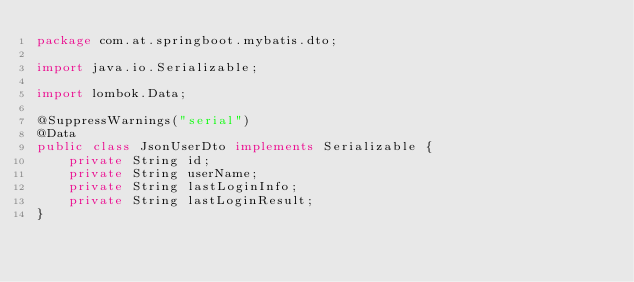Convert code to text. <code><loc_0><loc_0><loc_500><loc_500><_Java_>package com.at.springboot.mybatis.dto;

import java.io.Serializable;

import lombok.Data;

@SuppressWarnings("serial")
@Data
public class JsonUserDto implements Serializable {
    private String id;
    private String userName;
    private String lastLoginInfo;
    private String lastLoginResult;
}
</code> 